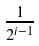<formula> <loc_0><loc_0><loc_500><loc_500>\frac { 1 } { 2 ^ { i - 1 } }</formula> 